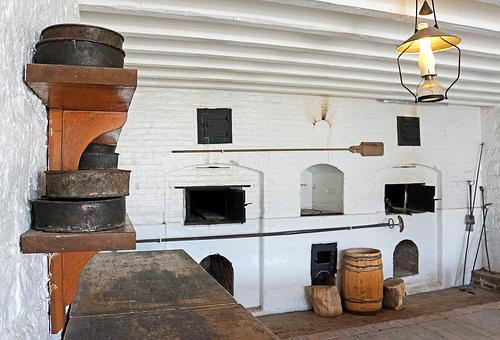Identify the primary object in the image and explain its purpose. The main object in the image is an old bakery, whose purpose is to prepare and bake various types of bread and pastries. Describe the tools used for handling bread in this image. In this image, there are items for shaping bread, tools for moving bread in the oven, and a large wood paddle as well as a peel for the oven. Mention the oven in the image and provide details about its state. The oven in the image is an old oven with its oven door open, indicating that it might be currently in use, or it was left open after recent use. What type of floor can be seen in the image, and what are the additional items on it? The floor is made of bricks, and additional items on it include a wooden barrel, a smaller barrel, and a large wooden plank. Point out any visible signs of wear and tear within the space. There are visible signs of wear and tear such as chipped paint on the walls, rust on the metal objects, and general aging on the wooden items. Examine the objects in the image related to baking and comment on their condition. The objects related to baking, such as the wooden paddle, metal tins, and the oven, show signs of extensive use with visible rust and wear. What type of lighting is used in the bakery, and where is it placed? The lighting in the bakery includes a hanging lantern from the ceiling, providing illumination throughout the space. Describe the storage system found in this antique kitchen. The storage system includes wooden shelves against the walls, filled with various metal tins and other baking-related items. List the items that are hanging in the image. Items hanging in the image include a lantern from the ceiling and various tools and utensils on the walls. Describe the ceiling and walls' appearance in the image. The ceiling has exposed wooden beams, and the walls are painted white with some areas showing signs of wear and chipped paint. Don't miss the intricate tapestry hanging on the right wall, depicting a classic medieval scene. No, it's not mentioned in the image. 